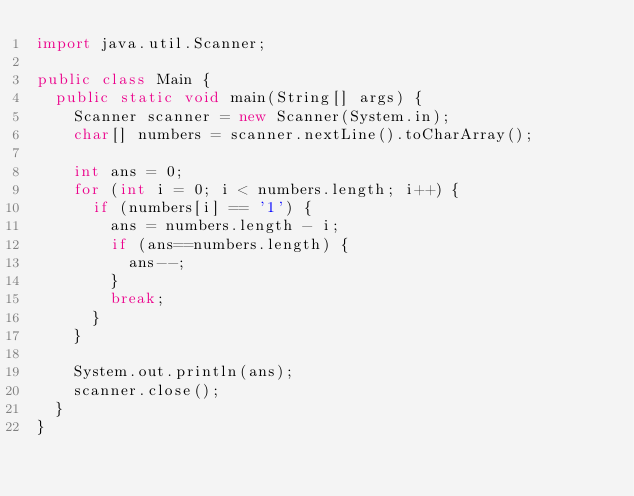<code> <loc_0><loc_0><loc_500><loc_500><_Java_>import java.util.Scanner;

public class Main {
	public static void main(String[] args) {
		Scanner scanner = new Scanner(System.in);
		char[] numbers = scanner.nextLine().toCharArray();
		
		int ans = 0;
		for (int i = 0; i < numbers.length; i++) {
			if (numbers[i] == '1') {
				ans = numbers.length - i;
				if (ans==numbers.length) {
					ans--;
				}
				break;
			}
		}
		
		System.out.println(ans);
		scanner.close();
	}
}
</code> 